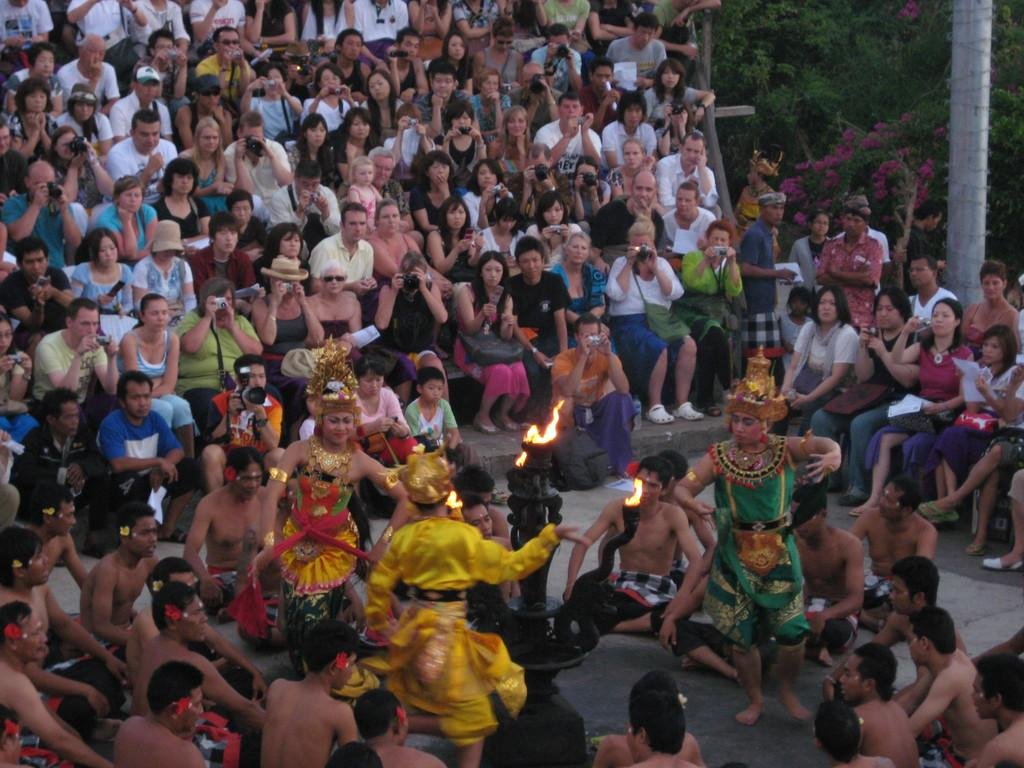How many people are present in the image? There are a few people in the image. What is the object with fire in the image? The object with fire is not specified, but it is present in the image. What can be used for climbing or support in the image? There is a pole in the image that can be used for climbing or support. What type of vegetation is visible in the image? There are a few trees in the image. What architectural feature is present in the image? There are some stairs in the image. What type of riddle is being solved by the people in the image? There is no riddle being solved by the people in the image; they are simply present in the scene. What is the consistency of the jelly in the image? There is no jelly present in the image. 